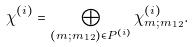<formula> <loc_0><loc_0><loc_500><loc_500>\chi ^ { ( i ) } = \bigoplus _ { ( m ; m _ { 1 2 } ) \in P ^ { ( i ) } } \chi ^ { ( i ) } _ { m ; m _ { 1 2 } } .</formula> 